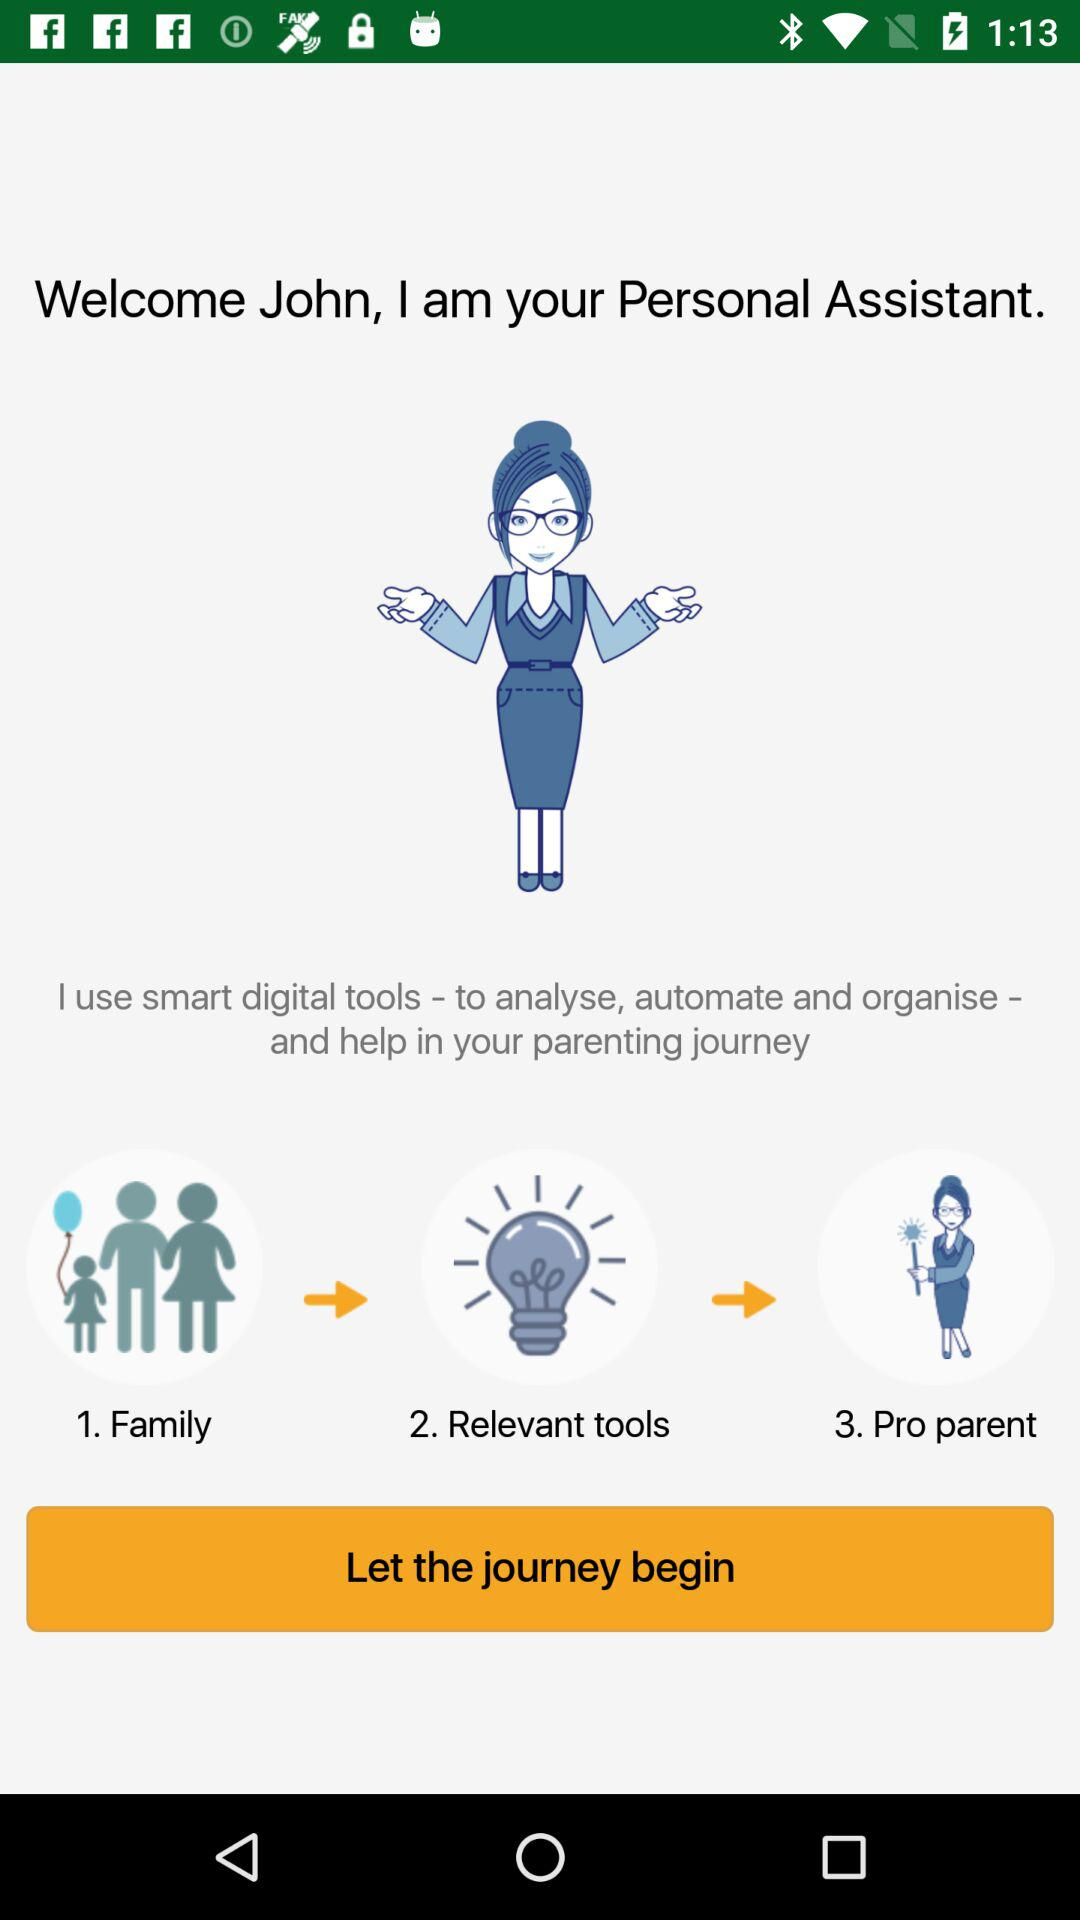What is the name of the user? The name of the user is John. 